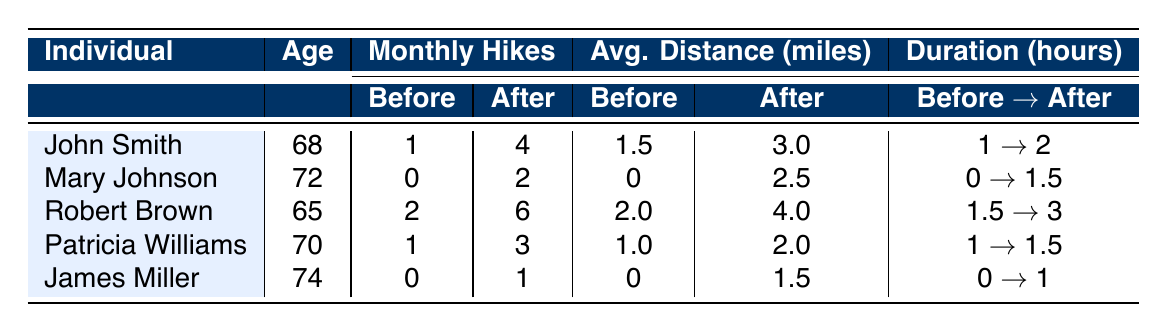What was the average number of monthly hikes after the intervention for all individuals? The monthly hikes after the intervention for each individual are: John Smith (4), Mary Johnson (2), Robert Brown (6), Patricia Williams (3), and James Miller (1). To find the average, sum these values: 4 + 2 + 6 + 3 + 1 = 16. Then, divide by the number of individuals: 16 / 5 = 3.2.
Answer: 3.2 Did any individual increase their monthly hikes more than three times after the intervention? John Smith increased from 1 to 4 (3 times), Robert Brown from 2 to 6 (4 times), and Patricia Williams from 1 to 3 (2 times). Thus, Robert Brown increased by more than three times.
Answer: Yes Which individual had the highest average distance hiked after the intervention? The average distances after the intervention are: John Smith (3.0), Mary Johnson (2.5), Robert Brown (4.0), Patricia Williams (2.0), and James Miller (1.5). The highest average distance is 4.0 by Robert Brown.
Answer: Robert Brown What is the total combined duration of hikes before the intervention? The durations before the intervention are: John Smith (1), Mary Johnson (0), Robert Brown (1.5), Patricia Williams (1), and James Miller (0). Adding these together: 1 + 0 + 1.5 + 1 + 0 = 3.5 hours.
Answer: 3.5 hours Was there any individual who did not hike at all before the intervention? By reviewing the table, Mary Johnson and James Miller both had 0 monthly hikes before the intervention, indicating they didn't hike at all.
Answer: Yes Which individual had the largest increase in average distance hiked from before to after the intervention? To find this, calculate the increases: John Smith (1.5 to 3.0, increase of 1.5), Mary Johnson (0 to 2.5, increase of 2.5), Robert Brown (2.0 to 4.0, increase of 2.0), Patricia Williams (1.0 to 2.0, increase of 1.0), and James Miller (0 to 1.5, increase of 1.5). The largest increase was by Mary Johnson with an increase of 2.5 miles.
Answer: Mary Johnson How many individuals had at least one hike per month after the intervention? The individuals with at least one hike per month after the intervention are John Smith (4), Mary Johnson (2), Robert Brown (6), Patricia Williams (3), and James Miller (1), totaling 5 individuals.
Answer: 5 Did any individual have the same number of hikes before and after the intervention? Looking at the data, John Smith, Robert Brown, and Patricia Williams all increased their hikes, while James Miller went from 0 to 1. Therefore, no individuals maintained the same amount of hikes before and after.
Answer: No 